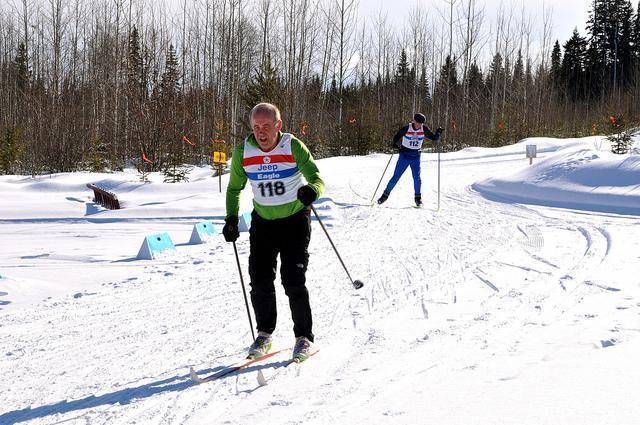What number is on the man in the green shirt's jersey?
Make your selection and explain in format: 'Answer: answer
Rationale: rationale.'
Options: 118, 415, 223, 956. Answer: 118.
Rationale: The number is visible and clear on his jersey. 